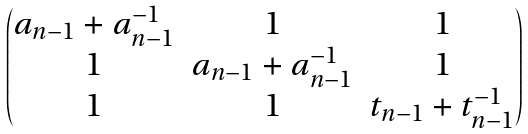<formula> <loc_0><loc_0><loc_500><loc_500>\begin{pmatrix} a _ { n - 1 } + a _ { n - 1 } ^ { - 1 } & 1 & 1 \\ 1 & a _ { n - 1 } + a _ { n - 1 } ^ { - 1 } & 1 \\ 1 & 1 & t _ { n - 1 } + t _ { n - 1 } ^ { - 1 } \end{pmatrix}</formula> 